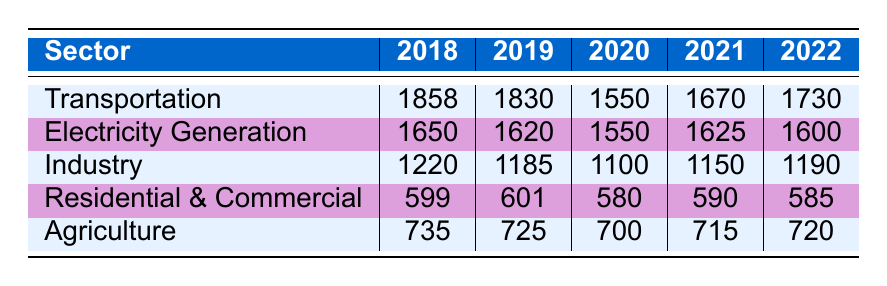What was the highest carbon emission sector in 2018? According to the table, the highest carbon emission sector in 2018 is Transportation with 1858 million tons of emissions.
Answer: Transportation What were the total carbon emissions from the Agriculture sector from 2018 to 2022? To find the total emissions from the Agriculture sector, we sum the emissions over these years: 735 + 725 + 700 + 715 + 720 = 3705 million tons.
Answer: 3705 million tons Did the carbon emissions from Electricity Generation increase from 2019 to 2020? The emissions from Electricity Generation in 2019 were 1620 million tons and dropped to 1550 million tons in 2020, indicating a decrease.
Answer: No Which sector had the largest decrease in emissions between 2018 and 2020? Calculating the decreases, Transportation decreased by 308 million tons (1858 to 1550), Electricity Generation decreased by 100 million tons (1650 to 1550), Industry decreased by 120 million tons (1220 to 1100), Residential & Commercial decreased by 14 million tons (599 to 580), and Agriculture decreased by 15 million tons (735 to 700). The largest decrease was in Transportation.
Answer: Transportation What is the average carbon emissions of the Industry sector from 2018 to 2022? The emissions for the Industry sector from 2018 to 2022 are: 1220, 1185, 1100, 1150, and 1190. To find the average, we sum them (1220 + 1185 + 1100 + 1150 + 1190 = 5935) and then divide by the number of years (5935 / 5 = 1187).
Answer: 1187 million tons In which year did the total emissions from the Residential & Commercial sector drop to its lowest point? The emissions in the Residential & Commercial sector are: 599 in 2018, 601 in 2019, 580 in 2020, 590 in 2021, and 585 in 2022. The lowest point occurred in 2020 with 580 million tons.
Answer: 2020 Were emissions from the Transportation sector lower in 2020 compared to 2019? The emissions in the Transportation sector were 1830 million tons in 2019 and 1550 million tons in 2020, showing a decrease in 2020.
Answer: Yes What was the change in carbon emissions in the Industry sector from 2021 to 2022? In 2021, the Industry sector emitted 1150 million tons, which increased to 1190 million tons in 2022. The change is therefore an increase of 40 million tons.
Answer: 40 million tons 